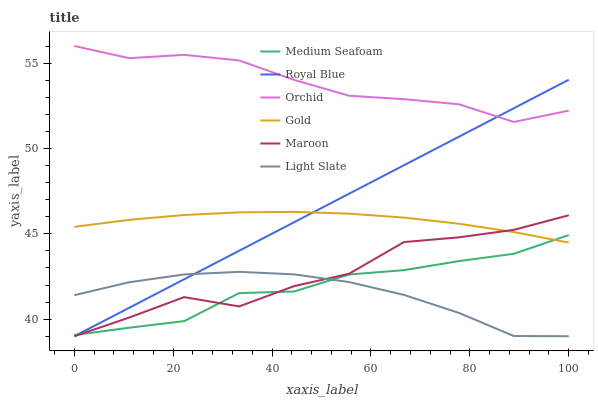Does Light Slate have the minimum area under the curve?
Answer yes or no. Yes. Does Orchid have the maximum area under the curve?
Answer yes or no. Yes. Does Maroon have the minimum area under the curve?
Answer yes or no. No. Does Maroon have the maximum area under the curve?
Answer yes or no. No. Is Royal Blue the smoothest?
Answer yes or no. Yes. Is Maroon the roughest?
Answer yes or no. Yes. Is Light Slate the smoothest?
Answer yes or no. No. Is Light Slate the roughest?
Answer yes or no. No. Does Light Slate have the lowest value?
Answer yes or no. Yes. Does Medium Seafoam have the lowest value?
Answer yes or no. No. Does Orchid have the highest value?
Answer yes or no. Yes. Does Maroon have the highest value?
Answer yes or no. No. Is Gold less than Orchid?
Answer yes or no. Yes. Is Orchid greater than Gold?
Answer yes or no. Yes. Does Royal Blue intersect Orchid?
Answer yes or no. Yes. Is Royal Blue less than Orchid?
Answer yes or no. No. Is Royal Blue greater than Orchid?
Answer yes or no. No. Does Gold intersect Orchid?
Answer yes or no. No. 